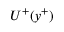Convert formula to latex. <formula><loc_0><loc_0><loc_500><loc_500>U ^ { + } ( y ^ { + } )</formula> 